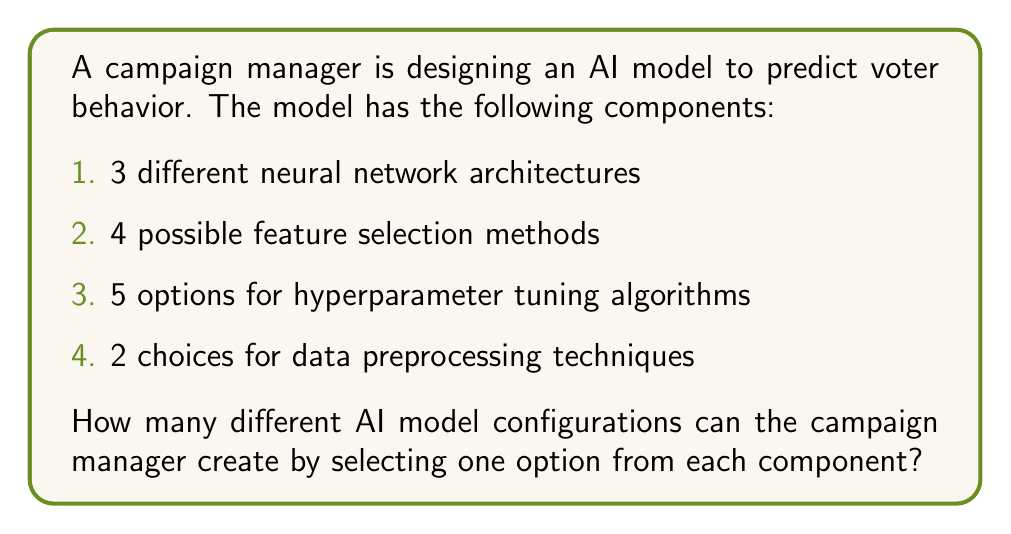Help me with this question. To solve this problem, we need to use the multiplication principle of counting. This principle states that if we have a series of independent choices, where the number of options for each choice is fixed, the total number of possible outcomes is the product of the number of options for each choice.

Let's break down the components:

1. Neural network architectures: 3 options
2. Feature selection methods: 4 options
3. Hyperparameter tuning algorithms: 5 options
4. Data preprocessing techniques: 2 options

Each of these components represents an independent choice, and we need to select one option from each component to create a complete AI model configuration.

The total number of possible configurations is:

$$ \text{Total configurations} = 3 \times 4 \times 5 \times 2 $$

Calculating this:

$$ \text{Total configurations} = 3 \times 4 \times 5 \times 2 = 120 $$

Therefore, the campaign manager can create 120 different AI model configurations for predicting voter behavior.
Answer: 120 different AI model configurations 